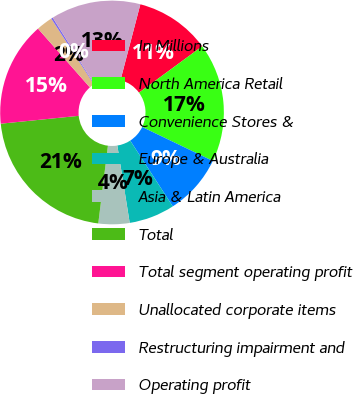<chart> <loc_0><loc_0><loc_500><loc_500><pie_chart><fcel>In Millions<fcel>North America Retail<fcel>Convenience Stores &<fcel>Europe & Australia<fcel>Asia & Latin America<fcel>Total<fcel>Total segment operating profit<fcel>Unallocated corporate items<fcel>Restructuring impairment and<fcel>Operating profit<nl><fcel>10.85%<fcel>17.21%<fcel>8.73%<fcel>6.61%<fcel>4.49%<fcel>21.44%<fcel>15.09%<fcel>2.37%<fcel>0.25%<fcel>12.97%<nl></chart> 